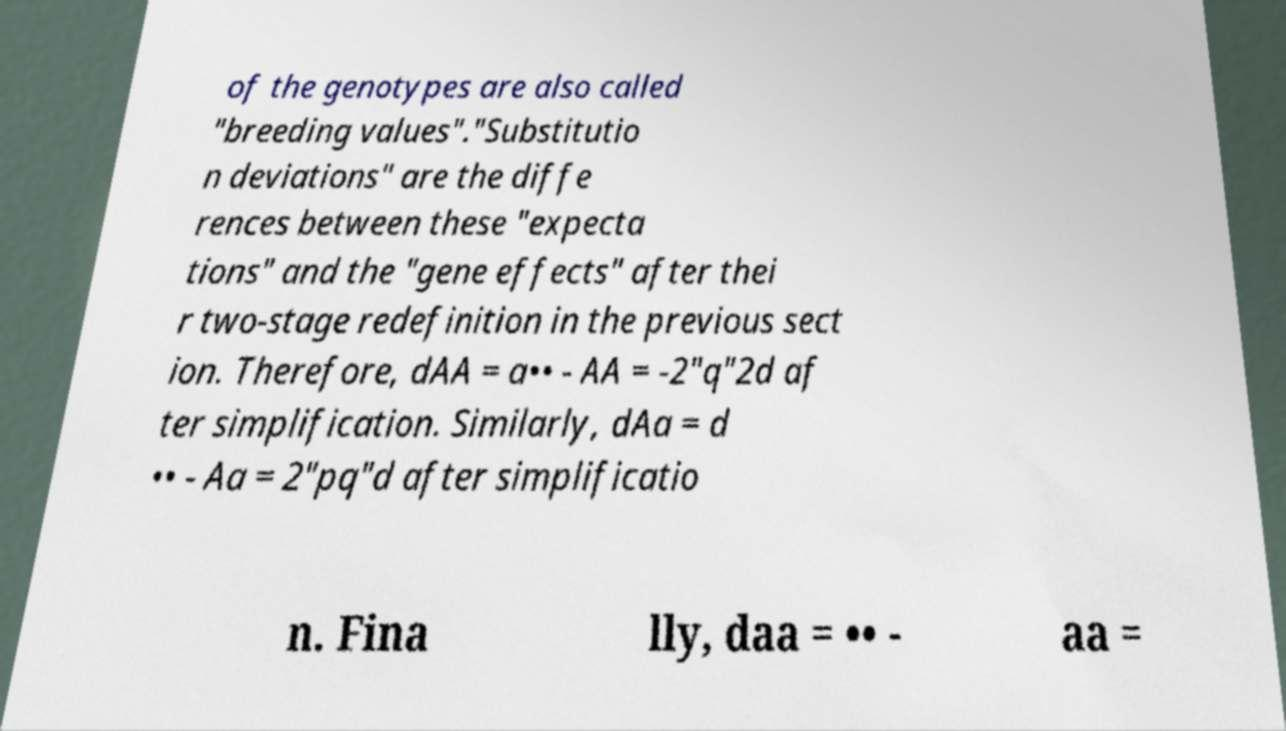I need the written content from this picture converted into text. Can you do that? of the genotypes are also called "breeding values"."Substitutio n deviations" are the diffe rences between these "expecta tions" and the "gene effects" after thei r two-stage redefinition in the previous sect ion. Therefore, dAA = a•• - AA = -2"q"2d af ter simplification. Similarly, dAa = d •• - Aa = 2"pq"d after simplificatio n. Fina lly, daa = •• - aa = 